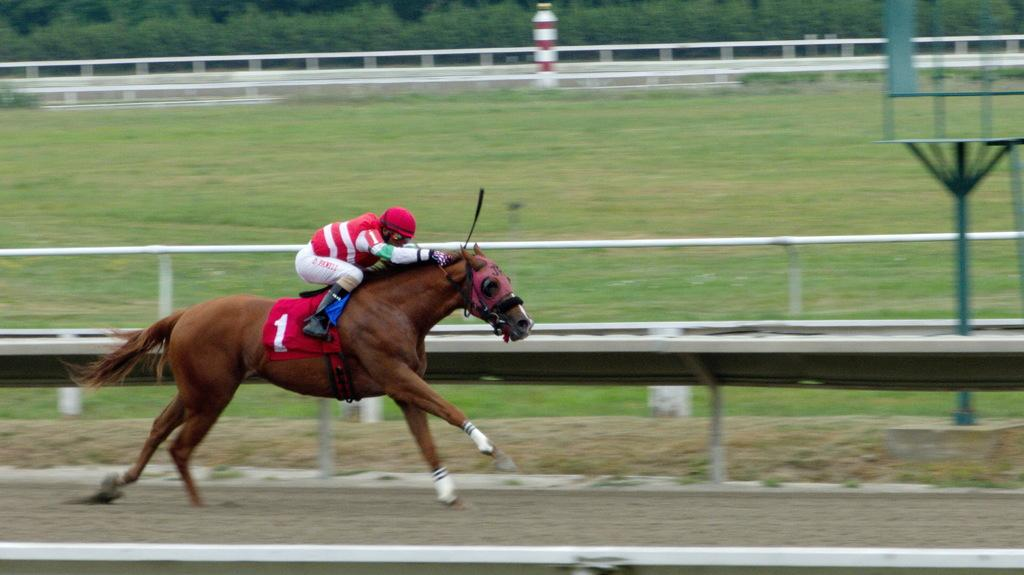What is the main subject of the image? The main subject of the image is a man. What is the man doing in the image? The man is riding a horse in the image. What is the horse's position in the image? The horse is on the ground in the image. What can be seen beside the horse? There is a fence beside the horse in the image. What type of vegetation is present on the ground? There is grass on the ground in the image. What can be seen in the background of the image? There are trees in the background of the image. What type of crook can be seen in the man's hand in the image? There is no crook present in the image; the man is riding a horse. What book is the horse reading while standing on the ground? There is no book present in the image, and horses do not read books. 